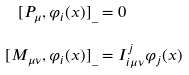Convert formula to latex. <formula><loc_0><loc_0><loc_500><loc_500>[ P _ { \mu } , \varphi _ { i } ( x ) ] _ { \_ } & = 0 \\ [ M _ { \mu \nu } , \varphi _ { i } ( x ) ] _ { \_ } & = I _ { i \mu \nu } ^ { j } \varphi _ { j } ( x )</formula> 